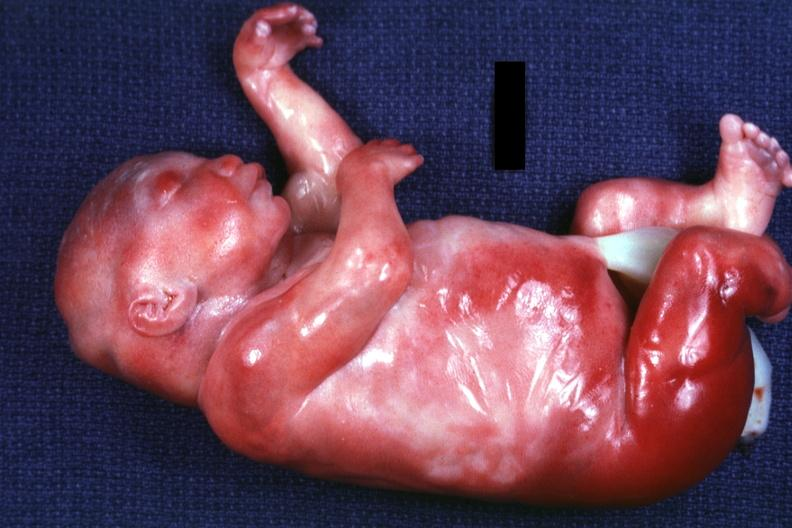does this image show lateral view of body with renal facies no neck?
Answer the question using a single word or phrase. Yes 